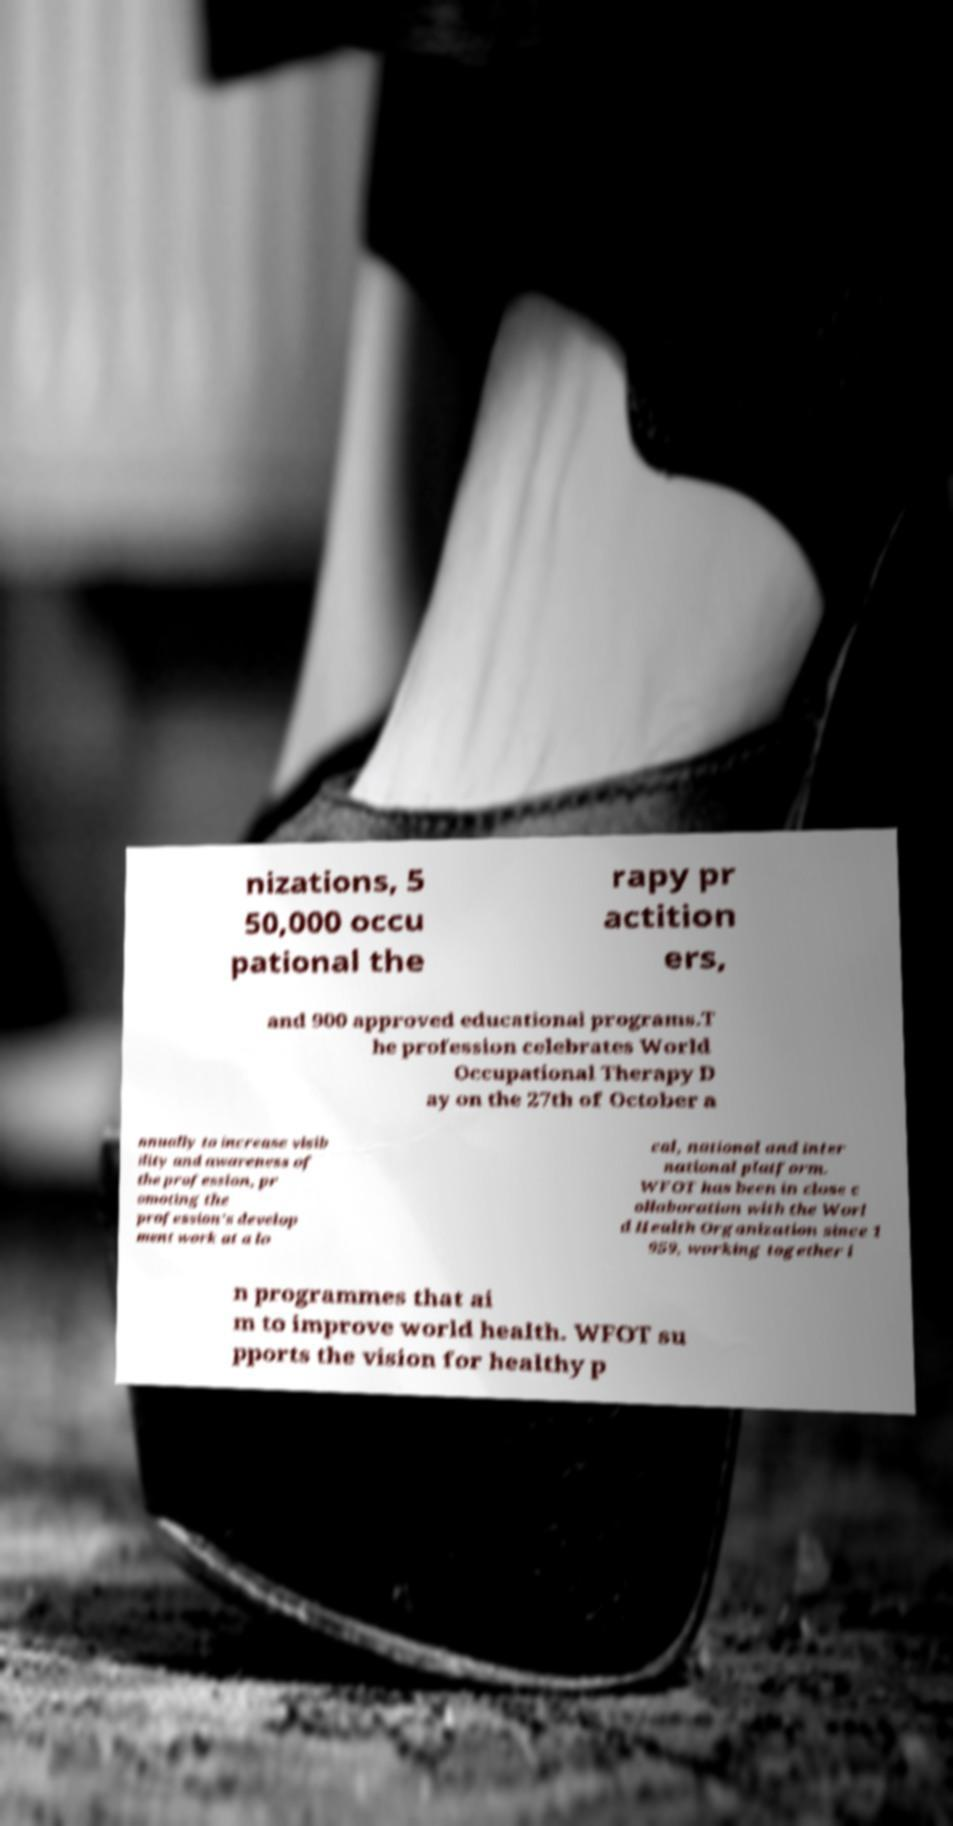Please identify and transcribe the text found in this image. nizations, 5 50,000 occu pational the rapy pr actition ers, and 900 approved educational programs.T he profession celebrates World Occupational Therapy D ay on the 27th of October a nnually to increase visib ility and awareness of the profession, pr omoting the profession's develop ment work at a lo cal, national and inter national platform. WFOT has been in close c ollaboration with the Worl d Health Organization since 1 959, working together i n programmes that ai m to improve world health. WFOT su pports the vision for healthy p 